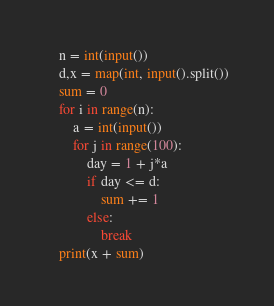Convert code to text. <code><loc_0><loc_0><loc_500><loc_500><_Python_>    n = int(input())
    d,x = map(int, input().split())
    sum = 0
    for i in range(n):
        a = int(input())
        for j in range(100):
            day = 1 + j*a
            if day <= d:
                sum += 1
            else:
                break
    print(x + sum)</code> 